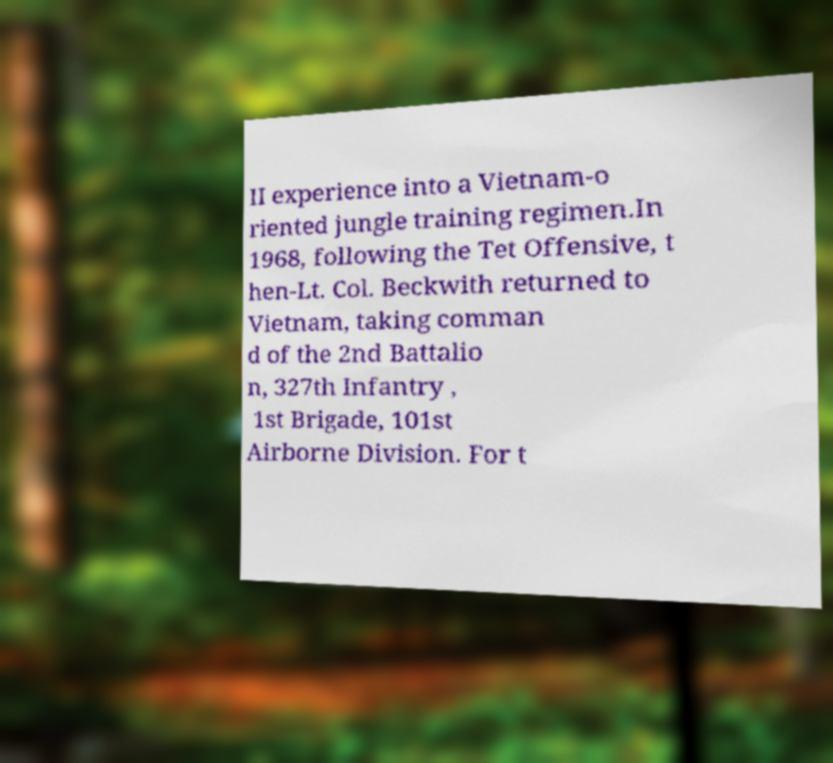Could you assist in decoding the text presented in this image and type it out clearly? II experience into a Vietnam-o riented jungle training regimen.In 1968, following the Tet Offensive, t hen-Lt. Col. Beckwith returned to Vietnam, taking comman d of the 2nd Battalio n, 327th Infantry , 1st Brigade, 101st Airborne Division. For t 